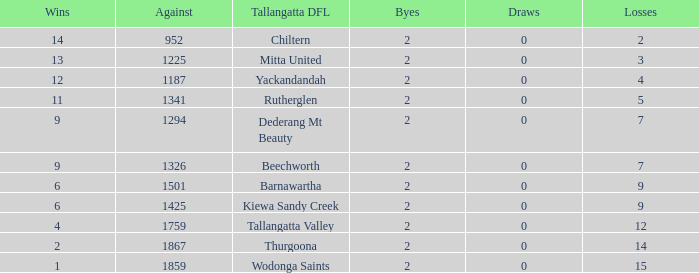What are the losses when there are 9 wins and more than 1326 against? None. 